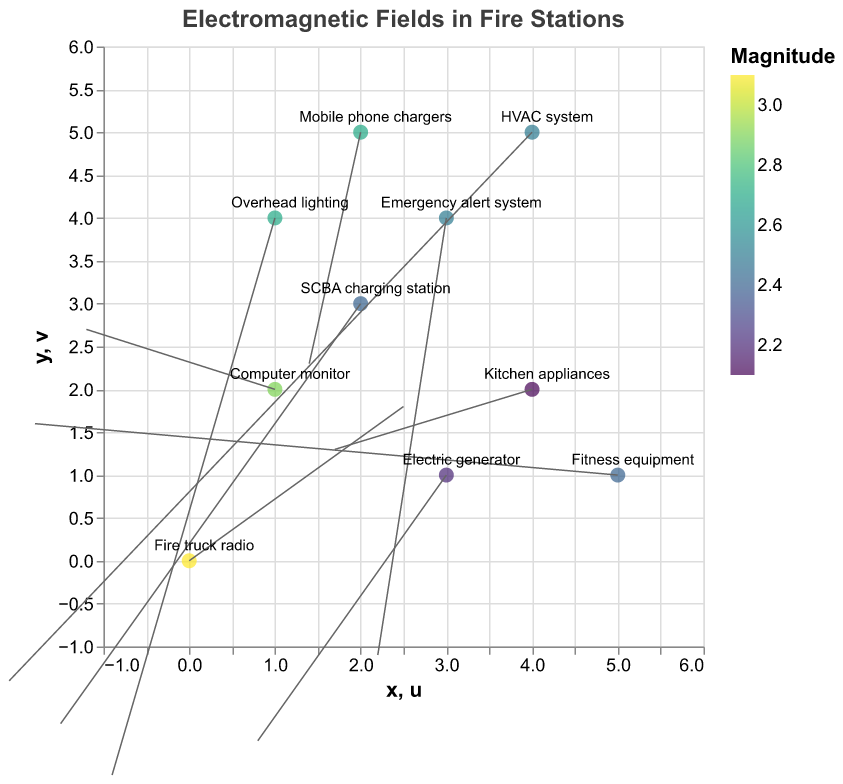What is the title of the plot? The title of the plot is displayed at the top.
Answer: Electromagnetic Fields in Fire Stations How many sources of electromagnetic fields are shown in the plot? There are individual data points, each representing a source of electromagnetic fields. By counting them, we find there are 10 sources.
Answer: 10 Which source has the highest magnitude of electromagnetic field? Observing the colors and tooltip associated with each point on the plot, the darkest color corresponds to the highest magnitude, which is 3.1. The tooltip shows that "Fire truck radio" has this value.
Answer: Fire truck radio Where is the "Emergency alert system" located on the plot? By referring to the text labels near each point, "Emergency alert system" is found at (3, 4).
Answer: (3, 4) What is the magnitude of the electromagnetic field from the "Computer monitor"? By locating the "Computer monitor" label and checking the tooltip, the magnitude is shown as 2.9.
Answer: 2.9 Which sources have an electromagnetic field magnitude of 2.7? Multiple points have the same magnitude by their color, and each can be verified in the tooltip. "Mobile phone chargers" and "Overhead lighting" both have a magnitude of 2.7.
Answer: Mobile phone chargers, Overhead lighting What are the u and v vector components for the "Electric generator"? By checking the attributes of "Electric generator" in the tooltip, the u and v components are found as 0.8 and -2.1, respectively.
Answer: 0.8, -2.1 Which direction does the vector from the "HVAC system" point? The vector direction is identified by the rule from the point (4, 5) to (4-2.1, 5-1.4), which gives the direction roughly southwest.
Answer: Southwest Is the magnitude of the "Fitness equipment" vector greater than that of the "SCBA charging station"? Comparing the values given in the tooltips, "Fitness equipment" has a magnitude of 2.4 and "SCBA charging station" has a magnitude of 2.4. They are equal.
Answer: No Which source is located at (4, 2), and what is its vector direction? By examining the plot for the position (4, 2), the source is "Kitchen appliances" and its vector direction is derived from (4, 2) to (4+1.7, 2+1.3), which is northeast.
Answer: Kitchen appliances, Northeast 